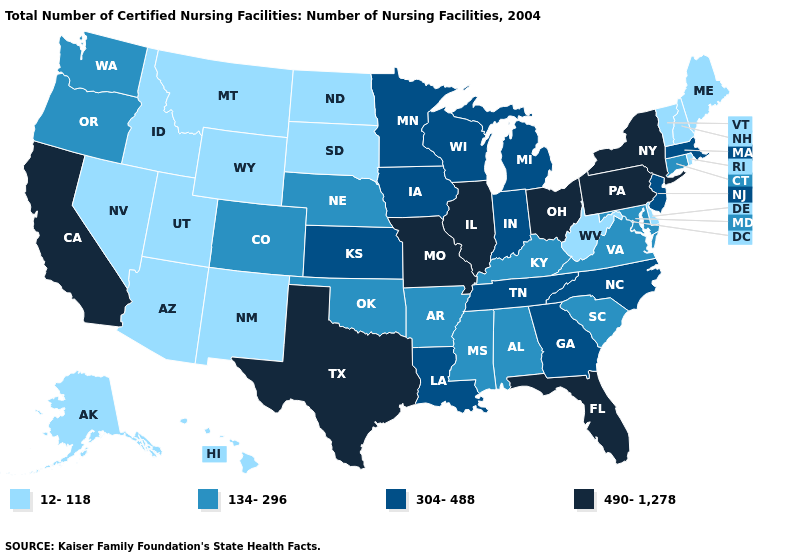What is the value of New Hampshire?
Quick response, please. 12-118. Among the states that border California , does Oregon have the highest value?
Concise answer only. Yes. Does West Virginia have the same value as Kentucky?
Answer briefly. No. What is the lowest value in states that border Oklahoma?
Concise answer only. 12-118. Is the legend a continuous bar?
Answer briefly. No. Name the states that have a value in the range 304-488?
Write a very short answer. Georgia, Indiana, Iowa, Kansas, Louisiana, Massachusetts, Michigan, Minnesota, New Jersey, North Carolina, Tennessee, Wisconsin. Name the states that have a value in the range 304-488?
Short answer required. Georgia, Indiana, Iowa, Kansas, Louisiana, Massachusetts, Michigan, Minnesota, New Jersey, North Carolina, Tennessee, Wisconsin. What is the highest value in the Northeast ?
Answer briefly. 490-1,278. Among the states that border Ohio , does Kentucky have the lowest value?
Be succinct. No. What is the value of Alabama?
Be succinct. 134-296. Does South Dakota have the highest value in the MidWest?
Short answer required. No. What is the value of Maine?
Short answer required. 12-118. Name the states that have a value in the range 134-296?
Answer briefly. Alabama, Arkansas, Colorado, Connecticut, Kentucky, Maryland, Mississippi, Nebraska, Oklahoma, Oregon, South Carolina, Virginia, Washington. Among the states that border Minnesota , does North Dakota have the highest value?
Quick response, please. No. Name the states that have a value in the range 490-1,278?
Be succinct. California, Florida, Illinois, Missouri, New York, Ohio, Pennsylvania, Texas. 